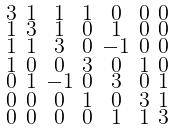<formula> <loc_0><loc_0><loc_500><loc_500>\begin{smallmatrix} 3 & 1 & 1 & 1 & 0 & 0 & 0 \\ 1 & 3 & 1 & 0 & 1 & 0 & 0 \\ 1 & 1 & 3 & 0 & - 1 & 0 & 0 \\ 1 & 0 & 0 & 3 & 0 & 1 & 0 \\ 0 & 1 & - 1 & 0 & 3 & 0 & 1 \\ 0 & 0 & 0 & 1 & 0 & 3 & 1 \\ 0 & 0 & 0 & 0 & 1 & 1 & 3 \end{smallmatrix}</formula> 